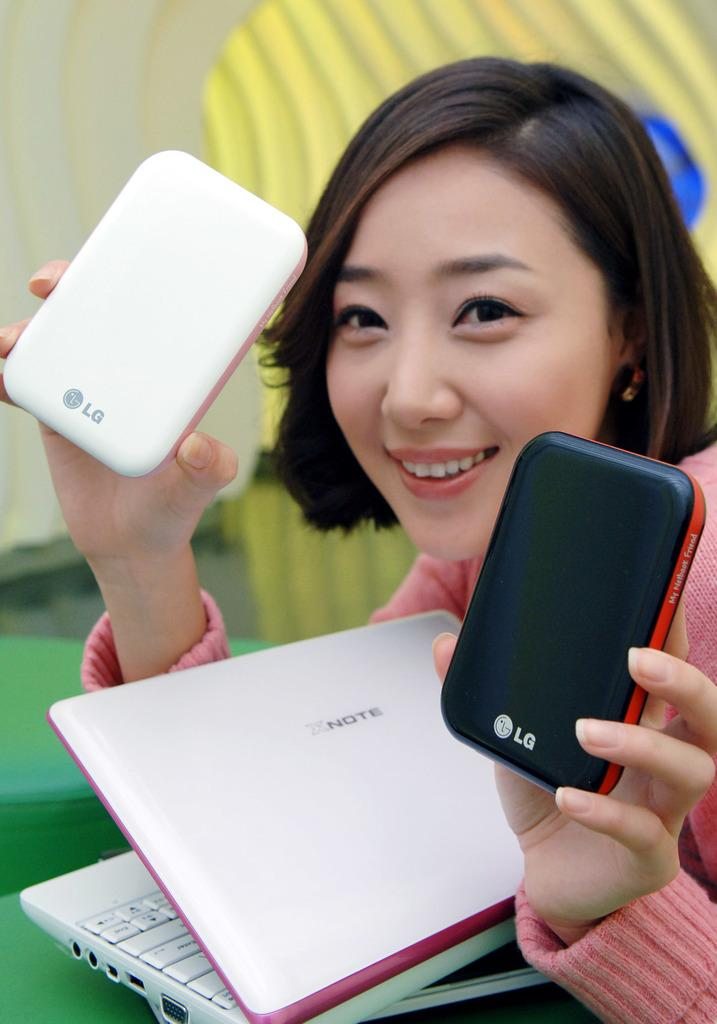<image>
Write a terse but informative summary of the picture. A lady holding two LG cell phones, p\one black and other white 